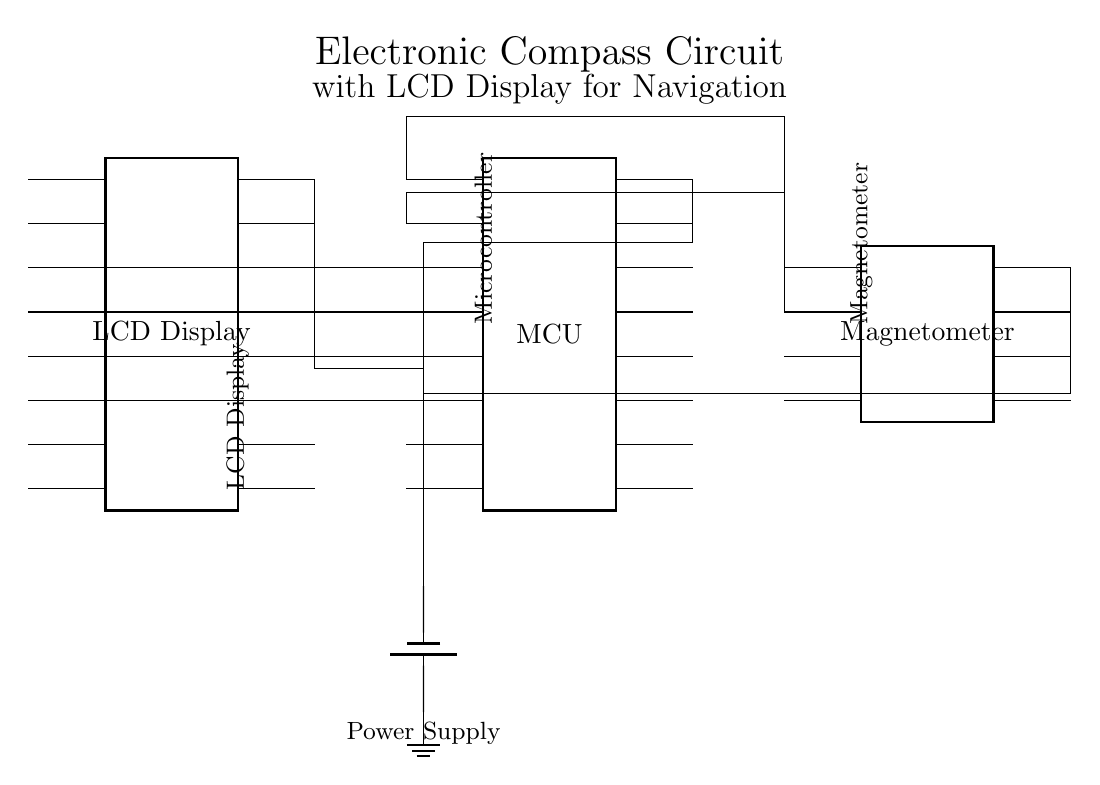What type of microcontroller is used in this circuit? The diagram does not specify the exact model of the microcontroller; it only indicates a generic microcontroller component.
Answer: Generic microcontroller What component is used to measure magnetic fields? The circuit includes a magnetometer that detects magnetic fields for navigation purposes.
Answer: Magnetometer How many pins does the LCD display have? The diagram shows that the LCD display has 16 pins, which are denoted on the schematic.
Answer: Sixteen pins What is the power supply configuration? The power supply is represented by a battery connected to the ground, indicating a direct current source for the circuit.
Answer: Battery with ground What is the connection type between the microcontroller and the magnetometer? The microcontroller connects to the magnetometer through multiple pin connections, indicating data communication necessary for reading compass directions.
Answer: Multi-pin connection Why is a magnetometer essential in this electronic compass circuit? The magnetometer measures the Earth's magnetic field, allowing the circuit to determine the direction relative to magnetic north, which is crucial for navigation.
Answer: Directional navigation 